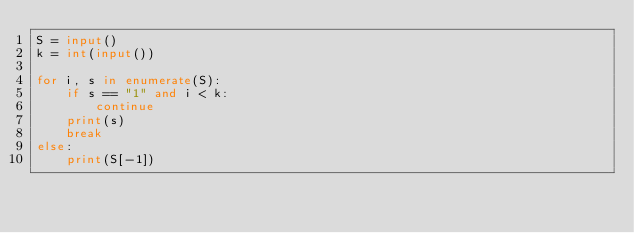<code> <loc_0><loc_0><loc_500><loc_500><_Python_>S = input()
k = int(input())

for i, s in enumerate(S):
    if s == "1" and i < k:
        continue
    print(s)
    break
else:
    print(S[-1])</code> 